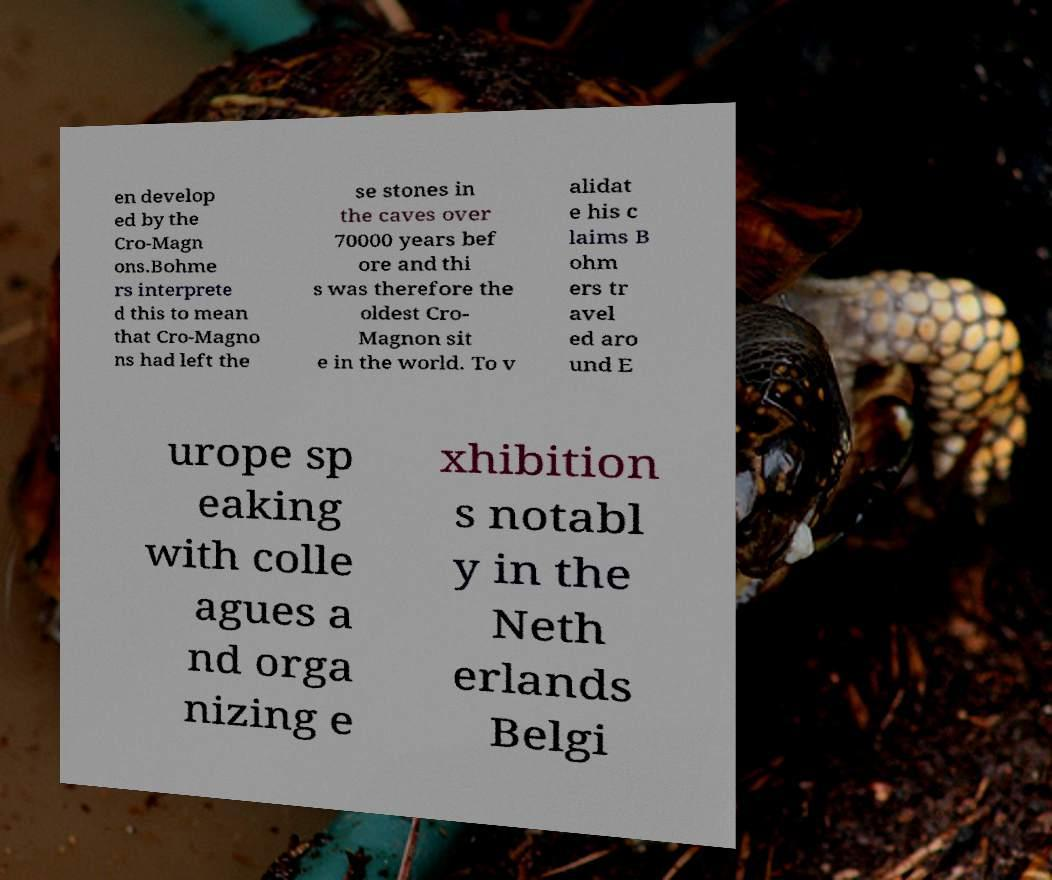Can you accurately transcribe the text from the provided image for me? en develop ed by the Cro-Magn ons.Bohme rs interprete d this to mean that Cro-Magno ns had left the se stones in the caves over 70000 years bef ore and thi s was therefore the oldest Cro- Magnon sit e in the world. To v alidat e his c laims B ohm ers tr avel ed aro und E urope sp eaking with colle agues a nd orga nizing e xhibition s notabl y in the Neth erlands Belgi 